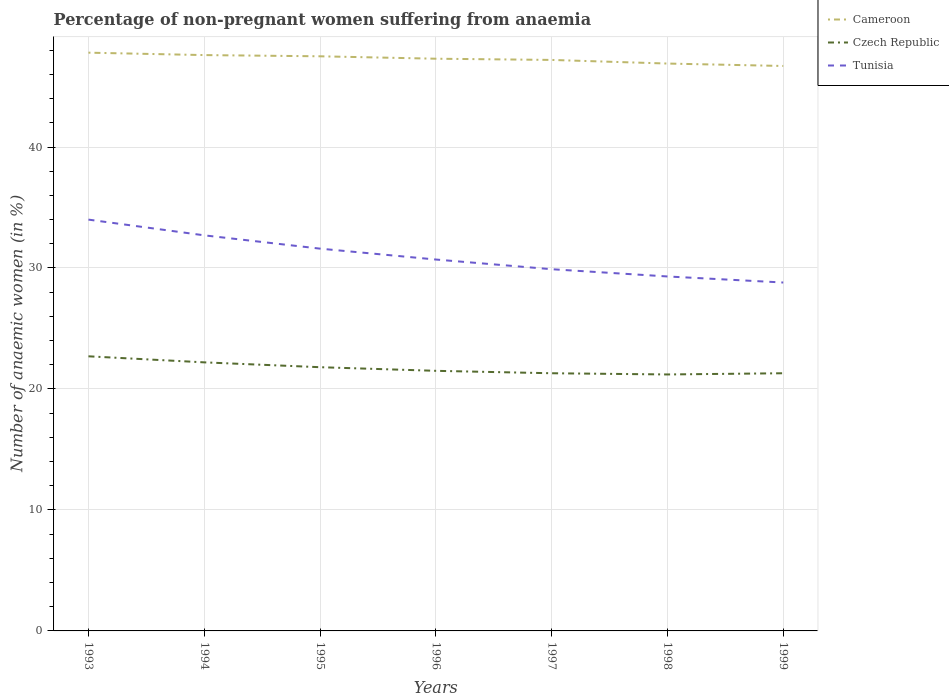Is the number of lines equal to the number of legend labels?
Keep it short and to the point. Yes. Across all years, what is the maximum percentage of non-pregnant women suffering from anaemia in Czech Republic?
Ensure brevity in your answer.  21.2. What is the total percentage of non-pregnant women suffering from anaemia in Cameroon in the graph?
Offer a terse response. 0.6. What is the difference between the highest and the second highest percentage of non-pregnant women suffering from anaemia in Tunisia?
Your answer should be very brief. 5.2. What is the difference between the highest and the lowest percentage of non-pregnant women suffering from anaemia in Cameroon?
Make the answer very short. 4. Is the percentage of non-pregnant women suffering from anaemia in Czech Republic strictly greater than the percentage of non-pregnant women suffering from anaemia in Tunisia over the years?
Provide a short and direct response. Yes. How many lines are there?
Your response must be concise. 3. What is the difference between two consecutive major ticks on the Y-axis?
Offer a terse response. 10. Does the graph contain any zero values?
Your response must be concise. No. What is the title of the graph?
Offer a terse response. Percentage of non-pregnant women suffering from anaemia. What is the label or title of the Y-axis?
Give a very brief answer. Number of anaemic women (in %). What is the Number of anaemic women (in %) in Cameroon in 1993?
Provide a succinct answer. 47.8. What is the Number of anaemic women (in %) in Czech Republic in 1993?
Provide a short and direct response. 22.7. What is the Number of anaemic women (in %) of Cameroon in 1994?
Offer a terse response. 47.6. What is the Number of anaemic women (in %) of Tunisia in 1994?
Keep it short and to the point. 32.7. What is the Number of anaemic women (in %) of Cameroon in 1995?
Your answer should be compact. 47.5. What is the Number of anaemic women (in %) in Czech Republic in 1995?
Ensure brevity in your answer.  21.8. What is the Number of anaemic women (in %) of Tunisia in 1995?
Your response must be concise. 31.6. What is the Number of anaemic women (in %) in Cameroon in 1996?
Your response must be concise. 47.3. What is the Number of anaemic women (in %) of Tunisia in 1996?
Make the answer very short. 30.7. What is the Number of anaemic women (in %) of Cameroon in 1997?
Ensure brevity in your answer.  47.2. What is the Number of anaemic women (in %) of Czech Republic in 1997?
Provide a succinct answer. 21.3. What is the Number of anaemic women (in %) of Tunisia in 1997?
Provide a succinct answer. 29.9. What is the Number of anaemic women (in %) of Cameroon in 1998?
Provide a short and direct response. 46.9. What is the Number of anaemic women (in %) of Czech Republic in 1998?
Your answer should be very brief. 21.2. What is the Number of anaemic women (in %) of Tunisia in 1998?
Your answer should be very brief. 29.3. What is the Number of anaemic women (in %) of Cameroon in 1999?
Offer a terse response. 46.7. What is the Number of anaemic women (in %) of Czech Republic in 1999?
Keep it short and to the point. 21.3. What is the Number of anaemic women (in %) in Tunisia in 1999?
Provide a succinct answer. 28.8. Across all years, what is the maximum Number of anaemic women (in %) of Cameroon?
Offer a very short reply. 47.8. Across all years, what is the maximum Number of anaemic women (in %) of Czech Republic?
Offer a terse response. 22.7. Across all years, what is the minimum Number of anaemic women (in %) in Cameroon?
Offer a very short reply. 46.7. Across all years, what is the minimum Number of anaemic women (in %) in Czech Republic?
Provide a short and direct response. 21.2. Across all years, what is the minimum Number of anaemic women (in %) in Tunisia?
Make the answer very short. 28.8. What is the total Number of anaemic women (in %) in Cameroon in the graph?
Offer a very short reply. 331. What is the total Number of anaemic women (in %) of Czech Republic in the graph?
Your answer should be very brief. 152. What is the total Number of anaemic women (in %) in Tunisia in the graph?
Provide a succinct answer. 217. What is the difference between the Number of anaemic women (in %) of Czech Republic in 1993 and that in 1994?
Your answer should be compact. 0.5. What is the difference between the Number of anaemic women (in %) in Tunisia in 1993 and that in 1995?
Provide a succinct answer. 2.4. What is the difference between the Number of anaemic women (in %) of Cameroon in 1993 and that in 1996?
Offer a terse response. 0.5. What is the difference between the Number of anaemic women (in %) in Czech Republic in 1993 and that in 1996?
Give a very brief answer. 1.2. What is the difference between the Number of anaemic women (in %) of Cameroon in 1993 and that in 1997?
Give a very brief answer. 0.6. What is the difference between the Number of anaemic women (in %) in Tunisia in 1993 and that in 1998?
Offer a terse response. 4.7. What is the difference between the Number of anaemic women (in %) of Tunisia in 1993 and that in 1999?
Your answer should be very brief. 5.2. What is the difference between the Number of anaemic women (in %) in Tunisia in 1994 and that in 1995?
Provide a succinct answer. 1.1. What is the difference between the Number of anaemic women (in %) of Cameroon in 1994 and that in 1996?
Provide a short and direct response. 0.3. What is the difference between the Number of anaemic women (in %) of Tunisia in 1994 and that in 1997?
Offer a terse response. 2.8. What is the difference between the Number of anaemic women (in %) in Cameroon in 1994 and that in 1998?
Provide a succinct answer. 0.7. What is the difference between the Number of anaemic women (in %) in Czech Republic in 1994 and that in 1998?
Provide a short and direct response. 1. What is the difference between the Number of anaemic women (in %) of Tunisia in 1994 and that in 1998?
Give a very brief answer. 3.4. What is the difference between the Number of anaemic women (in %) of Czech Republic in 1994 and that in 1999?
Offer a terse response. 0.9. What is the difference between the Number of anaemic women (in %) of Cameroon in 1995 and that in 1996?
Provide a succinct answer. 0.2. What is the difference between the Number of anaemic women (in %) of Tunisia in 1995 and that in 1996?
Your response must be concise. 0.9. What is the difference between the Number of anaemic women (in %) in Cameroon in 1996 and that in 1997?
Your answer should be compact. 0.1. What is the difference between the Number of anaemic women (in %) of Czech Republic in 1996 and that in 1997?
Provide a succinct answer. 0.2. What is the difference between the Number of anaemic women (in %) of Tunisia in 1996 and that in 1997?
Offer a terse response. 0.8. What is the difference between the Number of anaemic women (in %) in Cameroon in 1996 and that in 1998?
Provide a short and direct response. 0.4. What is the difference between the Number of anaemic women (in %) in Cameroon in 1996 and that in 1999?
Provide a short and direct response. 0.6. What is the difference between the Number of anaemic women (in %) of Czech Republic in 1996 and that in 1999?
Offer a terse response. 0.2. What is the difference between the Number of anaemic women (in %) in Tunisia in 1996 and that in 1999?
Offer a very short reply. 1.9. What is the difference between the Number of anaemic women (in %) in Cameroon in 1997 and that in 1998?
Your response must be concise. 0.3. What is the difference between the Number of anaemic women (in %) of Tunisia in 1997 and that in 1998?
Offer a very short reply. 0.6. What is the difference between the Number of anaemic women (in %) in Tunisia in 1997 and that in 1999?
Make the answer very short. 1.1. What is the difference between the Number of anaemic women (in %) of Cameroon in 1998 and that in 1999?
Your response must be concise. 0.2. What is the difference between the Number of anaemic women (in %) in Czech Republic in 1998 and that in 1999?
Provide a short and direct response. -0.1. What is the difference between the Number of anaemic women (in %) of Tunisia in 1998 and that in 1999?
Your answer should be very brief. 0.5. What is the difference between the Number of anaemic women (in %) in Cameroon in 1993 and the Number of anaemic women (in %) in Czech Republic in 1994?
Your answer should be very brief. 25.6. What is the difference between the Number of anaemic women (in %) in Cameroon in 1993 and the Number of anaemic women (in %) in Tunisia in 1994?
Keep it short and to the point. 15.1. What is the difference between the Number of anaemic women (in %) of Cameroon in 1993 and the Number of anaemic women (in %) of Czech Republic in 1996?
Your response must be concise. 26.3. What is the difference between the Number of anaemic women (in %) of Cameroon in 1993 and the Number of anaemic women (in %) of Tunisia in 1997?
Offer a very short reply. 17.9. What is the difference between the Number of anaemic women (in %) of Czech Republic in 1993 and the Number of anaemic women (in %) of Tunisia in 1997?
Your answer should be very brief. -7.2. What is the difference between the Number of anaemic women (in %) of Cameroon in 1993 and the Number of anaemic women (in %) of Czech Republic in 1998?
Your answer should be compact. 26.6. What is the difference between the Number of anaemic women (in %) in Czech Republic in 1993 and the Number of anaemic women (in %) in Tunisia in 1999?
Keep it short and to the point. -6.1. What is the difference between the Number of anaemic women (in %) of Cameroon in 1994 and the Number of anaemic women (in %) of Czech Republic in 1995?
Your answer should be very brief. 25.8. What is the difference between the Number of anaemic women (in %) of Cameroon in 1994 and the Number of anaemic women (in %) of Czech Republic in 1996?
Offer a very short reply. 26.1. What is the difference between the Number of anaemic women (in %) in Cameroon in 1994 and the Number of anaemic women (in %) in Tunisia in 1996?
Provide a short and direct response. 16.9. What is the difference between the Number of anaemic women (in %) in Cameroon in 1994 and the Number of anaemic women (in %) in Czech Republic in 1997?
Provide a short and direct response. 26.3. What is the difference between the Number of anaemic women (in %) of Cameroon in 1994 and the Number of anaemic women (in %) of Tunisia in 1997?
Your response must be concise. 17.7. What is the difference between the Number of anaemic women (in %) of Cameroon in 1994 and the Number of anaemic women (in %) of Czech Republic in 1998?
Ensure brevity in your answer.  26.4. What is the difference between the Number of anaemic women (in %) of Cameroon in 1994 and the Number of anaemic women (in %) of Czech Republic in 1999?
Your response must be concise. 26.3. What is the difference between the Number of anaemic women (in %) of Cameroon in 1994 and the Number of anaemic women (in %) of Tunisia in 1999?
Offer a terse response. 18.8. What is the difference between the Number of anaemic women (in %) in Cameroon in 1995 and the Number of anaemic women (in %) in Czech Republic in 1997?
Make the answer very short. 26.2. What is the difference between the Number of anaemic women (in %) in Cameroon in 1995 and the Number of anaemic women (in %) in Tunisia in 1997?
Give a very brief answer. 17.6. What is the difference between the Number of anaemic women (in %) in Czech Republic in 1995 and the Number of anaemic women (in %) in Tunisia in 1997?
Make the answer very short. -8.1. What is the difference between the Number of anaemic women (in %) in Cameroon in 1995 and the Number of anaemic women (in %) in Czech Republic in 1998?
Provide a succinct answer. 26.3. What is the difference between the Number of anaemic women (in %) in Cameroon in 1995 and the Number of anaemic women (in %) in Czech Republic in 1999?
Give a very brief answer. 26.2. What is the difference between the Number of anaemic women (in %) of Cameroon in 1996 and the Number of anaemic women (in %) of Czech Republic in 1997?
Your response must be concise. 26. What is the difference between the Number of anaemic women (in %) in Cameroon in 1996 and the Number of anaemic women (in %) in Tunisia in 1997?
Ensure brevity in your answer.  17.4. What is the difference between the Number of anaemic women (in %) of Czech Republic in 1996 and the Number of anaemic women (in %) of Tunisia in 1997?
Ensure brevity in your answer.  -8.4. What is the difference between the Number of anaemic women (in %) in Cameroon in 1996 and the Number of anaemic women (in %) in Czech Republic in 1998?
Your answer should be very brief. 26.1. What is the difference between the Number of anaemic women (in %) of Czech Republic in 1996 and the Number of anaemic women (in %) of Tunisia in 1998?
Provide a succinct answer. -7.8. What is the difference between the Number of anaemic women (in %) in Cameroon in 1996 and the Number of anaemic women (in %) in Czech Republic in 1999?
Provide a short and direct response. 26. What is the difference between the Number of anaemic women (in %) of Cameroon in 1997 and the Number of anaemic women (in %) of Czech Republic in 1998?
Offer a very short reply. 26. What is the difference between the Number of anaemic women (in %) of Czech Republic in 1997 and the Number of anaemic women (in %) of Tunisia in 1998?
Keep it short and to the point. -8. What is the difference between the Number of anaemic women (in %) of Cameroon in 1997 and the Number of anaemic women (in %) of Czech Republic in 1999?
Your answer should be very brief. 25.9. What is the difference between the Number of anaemic women (in %) of Cameroon in 1998 and the Number of anaemic women (in %) of Czech Republic in 1999?
Your answer should be compact. 25.6. What is the average Number of anaemic women (in %) in Cameroon per year?
Your response must be concise. 47.29. What is the average Number of anaemic women (in %) in Czech Republic per year?
Your answer should be compact. 21.71. What is the average Number of anaemic women (in %) in Tunisia per year?
Keep it short and to the point. 31. In the year 1993, what is the difference between the Number of anaemic women (in %) in Cameroon and Number of anaemic women (in %) in Czech Republic?
Provide a succinct answer. 25.1. In the year 1993, what is the difference between the Number of anaemic women (in %) in Cameroon and Number of anaemic women (in %) in Tunisia?
Make the answer very short. 13.8. In the year 1994, what is the difference between the Number of anaemic women (in %) in Cameroon and Number of anaemic women (in %) in Czech Republic?
Make the answer very short. 25.4. In the year 1995, what is the difference between the Number of anaemic women (in %) of Cameroon and Number of anaemic women (in %) of Czech Republic?
Your answer should be very brief. 25.7. In the year 1996, what is the difference between the Number of anaemic women (in %) of Cameroon and Number of anaemic women (in %) of Czech Republic?
Provide a succinct answer. 25.8. In the year 1997, what is the difference between the Number of anaemic women (in %) of Cameroon and Number of anaemic women (in %) of Czech Republic?
Keep it short and to the point. 25.9. In the year 1997, what is the difference between the Number of anaemic women (in %) in Cameroon and Number of anaemic women (in %) in Tunisia?
Make the answer very short. 17.3. In the year 1997, what is the difference between the Number of anaemic women (in %) of Czech Republic and Number of anaemic women (in %) of Tunisia?
Your response must be concise. -8.6. In the year 1998, what is the difference between the Number of anaemic women (in %) in Cameroon and Number of anaemic women (in %) in Czech Republic?
Keep it short and to the point. 25.7. In the year 1999, what is the difference between the Number of anaemic women (in %) of Cameroon and Number of anaemic women (in %) of Czech Republic?
Provide a succinct answer. 25.4. In the year 1999, what is the difference between the Number of anaemic women (in %) in Czech Republic and Number of anaemic women (in %) in Tunisia?
Make the answer very short. -7.5. What is the ratio of the Number of anaemic women (in %) of Cameroon in 1993 to that in 1994?
Keep it short and to the point. 1. What is the ratio of the Number of anaemic women (in %) of Czech Republic in 1993 to that in 1994?
Keep it short and to the point. 1.02. What is the ratio of the Number of anaemic women (in %) in Tunisia in 1993 to that in 1994?
Ensure brevity in your answer.  1.04. What is the ratio of the Number of anaemic women (in %) of Czech Republic in 1993 to that in 1995?
Offer a terse response. 1.04. What is the ratio of the Number of anaemic women (in %) in Tunisia in 1993 to that in 1995?
Your response must be concise. 1.08. What is the ratio of the Number of anaemic women (in %) of Cameroon in 1993 to that in 1996?
Give a very brief answer. 1.01. What is the ratio of the Number of anaemic women (in %) in Czech Republic in 1993 to that in 1996?
Your response must be concise. 1.06. What is the ratio of the Number of anaemic women (in %) of Tunisia in 1993 to that in 1996?
Your response must be concise. 1.11. What is the ratio of the Number of anaemic women (in %) in Cameroon in 1993 to that in 1997?
Give a very brief answer. 1.01. What is the ratio of the Number of anaemic women (in %) in Czech Republic in 1993 to that in 1997?
Make the answer very short. 1.07. What is the ratio of the Number of anaemic women (in %) of Tunisia in 1993 to that in 1997?
Keep it short and to the point. 1.14. What is the ratio of the Number of anaemic women (in %) in Cameroon in 1993 to that in 1998?
Give a very brief answer. 1.02. What is the ratio of the Number of anaemic women (in %) in Czech Republic in 1993 to that in 1998?
Keep it short and to the point. 1.07. What is the ratio of the Number of anaemic women (in %) of Tunisia in 1993 to that in 1998?
Your response must be concise. 1.16. What is the ratio of the Number of anaemic women (in %) of Cameroon in 1993 to that in 1999?
Give a very brief answer. 1.02. What is the ratio of the Number of anaemic women (in %) in Czech Republic in 1993 to that in 1999?
Make the answer very short. 1.07. What is the ratio of the Number of anaemic women (in %) in Tunisia in 1993 to that in 1999?
Your response must be concise. 1.18. What is the ratio of the Number of anaemic women (in %) in Czech Republic in 1994 to that in 1995?
Provide a succinct answer. 1.02. What is the ratio of the Number of anaemic women (in %) in Tunisia in 1994 to that in 1995?
Provide a succinct answer. 1.03. What is the ratio of the Number of anaemic women (in %) in Cameroon in 1994 to that in 1996?
Your response must be concise. 1.01. What is the ratio of the Number of anaemic women (in %) in Czech Republic in 1994 to that in 1996?
Provide a short and direct response. 1.03. What is the ratio of the Number of anaemic women (in %) in Tunisia in 1994 to that in 1996?
Provide a succinct answer. 1.07. What is the ratio of the Number of anaemic women (in %) in Cameroon in 1994 to that in 1997?
Offer a terse response. 1.01. What is the ratio of the Number of anaemic women (in %) of Czech Republic in 1994 to that in 1997?
Your answer should be very brief. 1.04. What is the ratio of the Number of anaemic women (in %) in Tunisia in 1994 to that in 1997?
Offer a very short reply. 1.09. What is the ratio of the Number of anaemic women (in %) of Cameroon in 1994 to that in 1998?
Give a very brief answer. 1.01. What is the ratio of the Number of anaemic women (in %) in Czech Republic in 1994 to that in 1998?
Your response must be concise. 1.05. What is the ratio of the Number of anaemic women (in %) in Tunisia in 1994 to that in 1998?
Give a very brief answer. 1.12. What is the ratio of the Number of anaemic women (in %) of Cameroon in 1994 to that in 1999?
Provide a short and direct response. 1.02. What is the ratio of the Number of anaemic women (in %) of Czech Republic in 1994 to that in 1999?
Ensure brevity in your answer.  1.04. What is the ratio of the Number of anaemic women (in %) of Tunisia in 1994 to that in 1999?
Your answer should be very brief. 1.14. What is the ratio of the Number of anaemic women (in %) in Cameroon in 1995 to that in 1996?
Ensure brevity in your answer.  1. What is the ratio of the Number of anaemic women (in %) of Tunisia in 1995 to that in 1996?
Make the answer very short. 1.03. What is the ratio of the Number of anaemic women (in %) of Cameroon in 1995 to that in 1997?
Give a very brief answer. 1.01. What is the ratio of the Number of anaemic women (in %) of Czech Republic in 1995 to that in 1997?
Provide a succinct answer. 1.02. What is the ratio of the Number of anaemic women (in %) of Tunisia in 1995 to that in 1997?
Provide a succinct answer. 1.06. What is the ratio of the Number of anaemic women (in %) in Cameroon in 1995 to that in 1998?
Your response must be concise. 1.01. What is the ratio of the Number of anaemic women (in %) of Czech Republic in 1995 to that in 1998?
Offer a very short reply. 1.03. What is the ratio of the Number of anaemic women (in %) in Tunisia in 1995 to that in 1998?
Offer a very short reply. 1.08. What is the ratio of the Number of anaemic women (in %) in Cameroon in 1995 to that in 1999?
Provide a short and direct response. 1.02. What is the ratio of the Number of anaemic women (in %) in Czech Republic in 1995 to that in 1999?
Provide a succinct answer. 1.02. What is the ratio of the Number of anaemic women (in %) in Tunisia in 1995 to that in 1999?
Give a very brief answer. 1.1. What is the ratio of the Number of anaemic women (in %) of Czech Republic in 1996 to that in 1997?
Your response must be concise. 1.01. What is the ratio of the Number of anaemic women (in %) in Tunisia in 1996 to that in 1997?
Ensure brevity in your answer.  1.03. What is the ratio of the Number of anaemic women (in %) in Cameroon in 1996 to that in 1998?
Offer a terse response. 1.01. What is the ratio of the Number of anaemic women (in %) in Czech Republic in 1996 to that in 1998?
Make the answer very short. 1.01. What is the ratio of the Number of anaemic women (in %) in Tunisia in 1996 to that in 1998?
Your response must be concise. 1.05. What is the ratio of the Number of anaemic women (in %) of Cameroon in 1996 to that in 1999?
Keep it short and to the point. 1.01. What is the ratio of the Number of anaemic women (in %) in Czech Republic in 1996 to that in 1999?
Your answer should be compact. 1.01. What is the ratio of the Number of anaemic women (in %) in Tunisia in 1996 to that in 1999?
Your answer should be very brief. 1.07. What is the ratio of the Number of anaemic women (in %) in Cameroon in 1997 to that in 1998?
Provide a short and direct response. 1.01. What is the ratio of the Number of anaemic women (in %) of Czech Republic in 1997 to that in 1998?
Your response must be concise. 1. What is the ratio of the Number of anaemic women (in %) in Tunisia in 1997 to that in 1998?
Keep it short and to the point. 1.02. What is the ratio of the Number of anaemic women (in %) in Cameroon in 1997 to that in 1999?
Provide a succinct answer. 1.01. What is the ratio of the Number of anaemic women (in %) in Czech Republic in 1997 to that in 1999?
Ensure brevity in your answer.  1. What is the ratio of the Number of anaemic women (in %) of Tunisia in 1997 to that in 1999?
Your response must be concise. 1.04. What is the ratio of the Number of anaemic women (in %) of Tunisia in 1998 to that in 1999?
Ensure brevity in your answer.  1.02. What is the difference between the highest and the lowest Number of anaemic women (in %) of Tunisia?
Your answer should be compact. 5.2. 